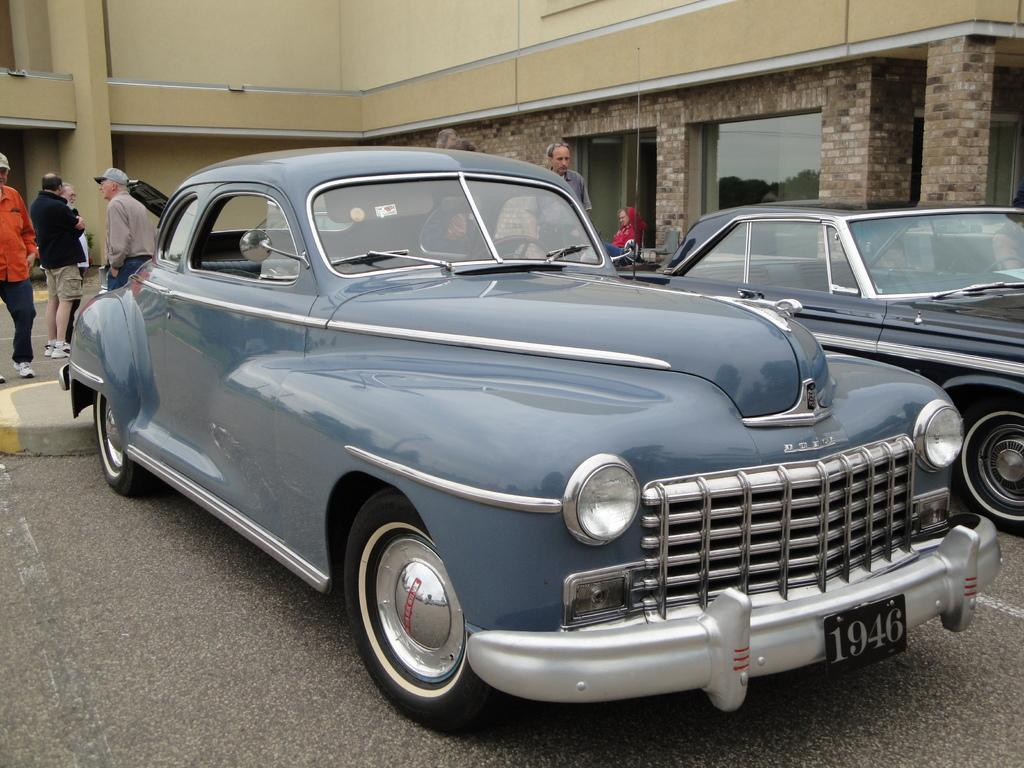How many cars are parked in the image? There are two cars parked in the image. What are the people behind the cars doing? There are people standing behind the cars. What is the activity of some people in the image? Some people are walking in the image. What can be seen in the distance in the image? There is a building in the background of the image. Can you see a knot tied on the window in the image? There is no window or knot present in the image. What type of rake is being used by the people in the image? There are no rakes or people using rakes in the image. 